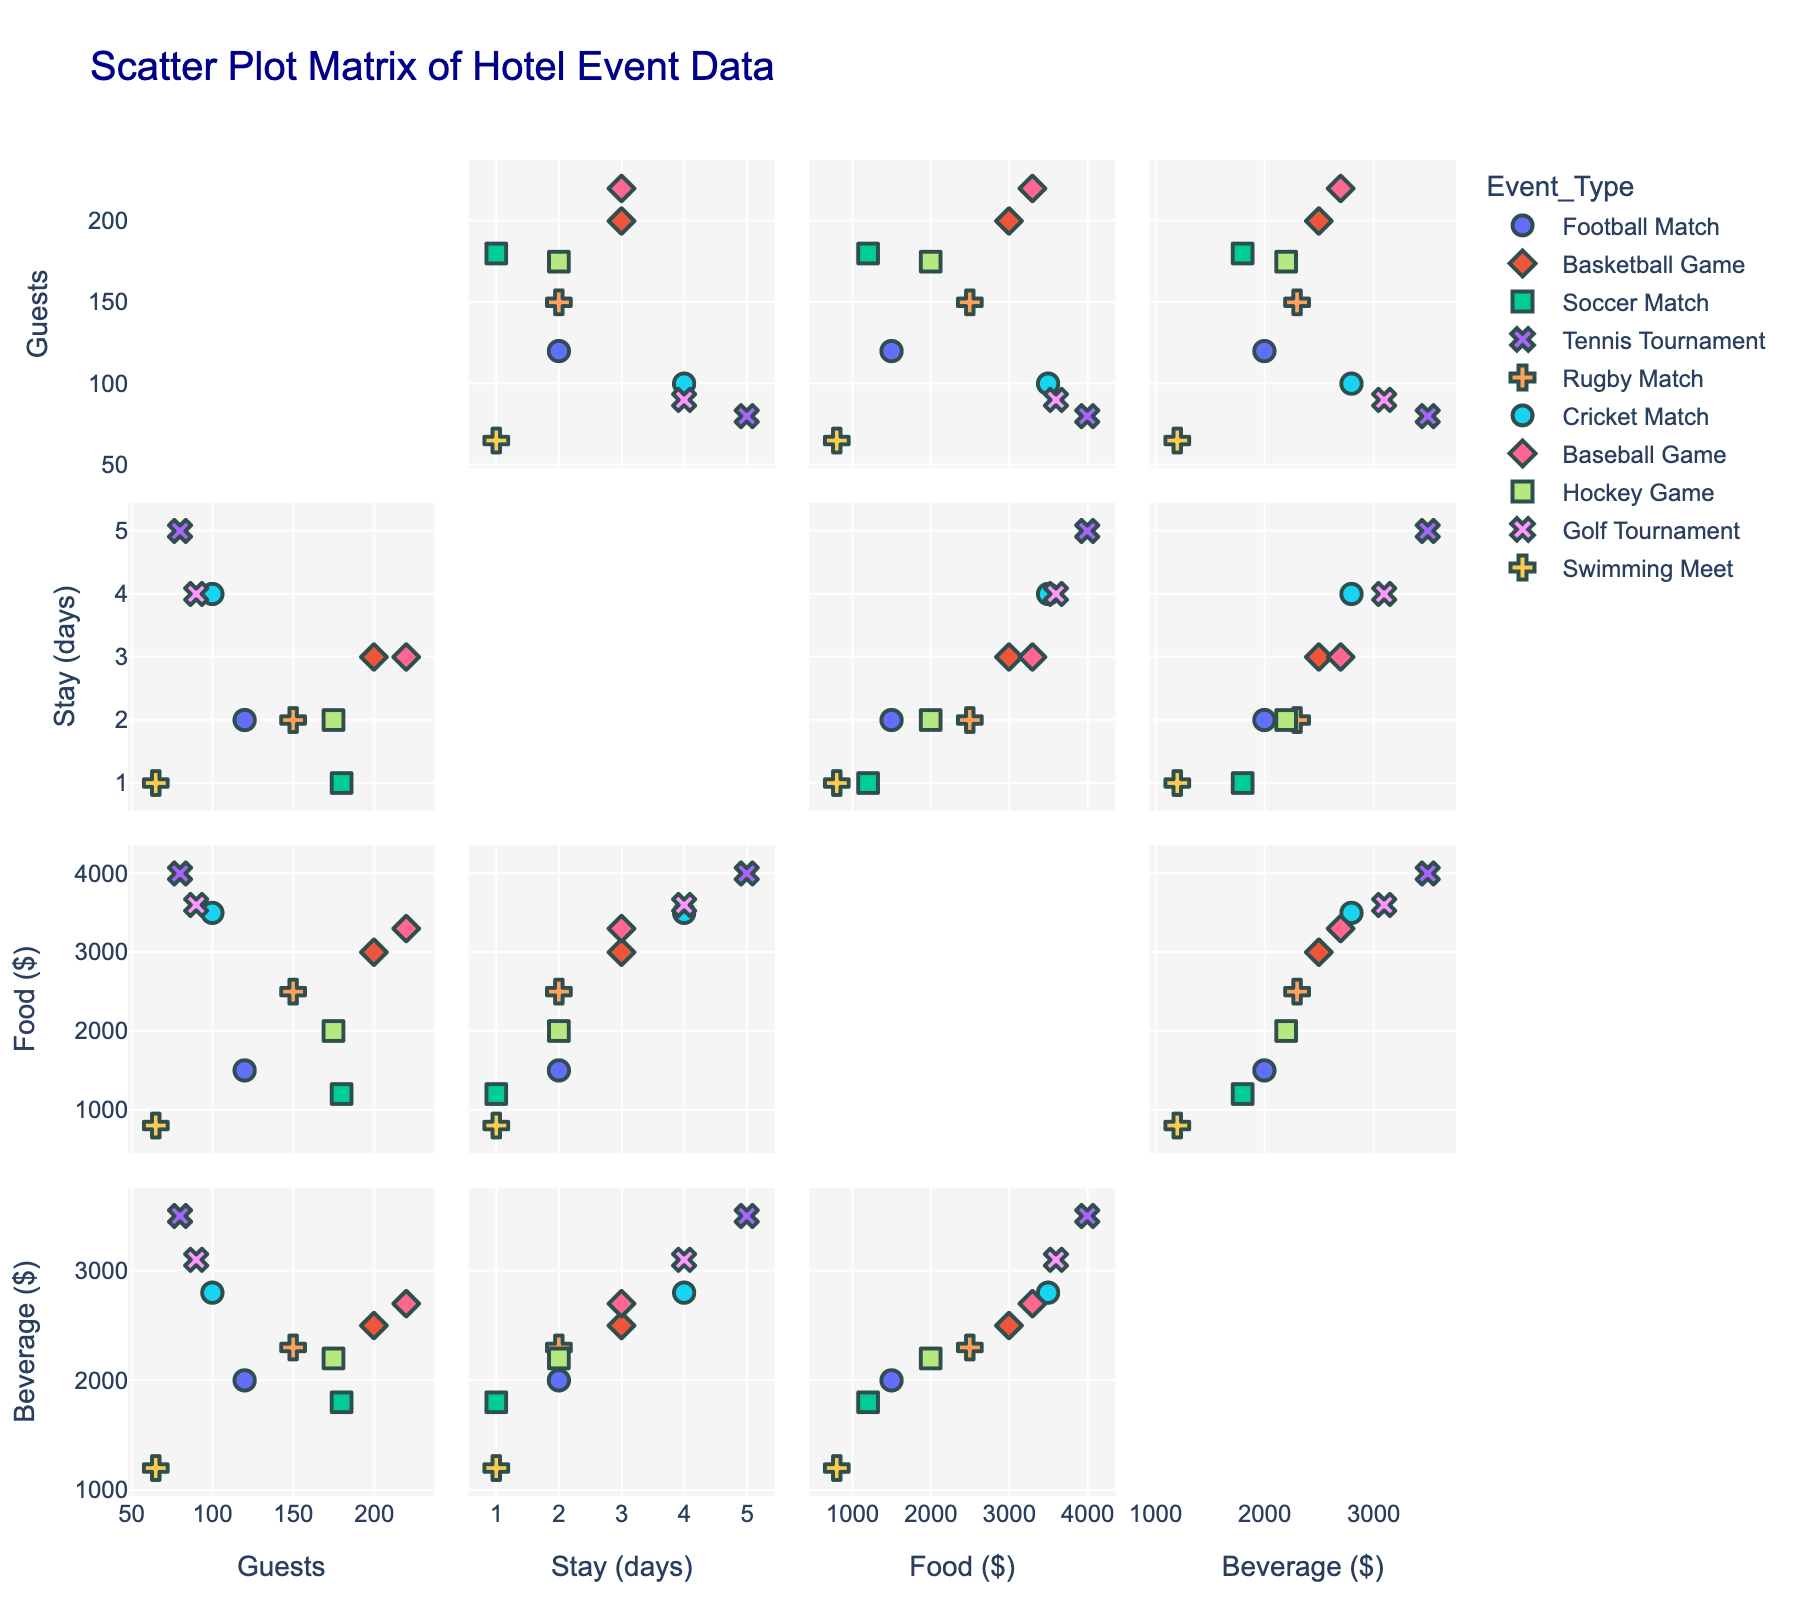How many events are represented in the scatter plot matrix? Count the number of distinct symbols or colors representing different events. Each unique color or symbol corresponds to a distinct event.
Answer: 10 Which event type has the highest number of guests? Look at the "Number_of_Guests" dimension and identify the event type with the highest data point.
Answer: Baseball Game What's the average duration of stay for Football Matches and Basketball Games? Find the data points for Football Matches and Basketball Games in the "Duration_of_Stay" dimension, and calculate the average of these durations. For Football Matches, the duration is 2 days, and for Basketball Games, it is 3 days. The average is (2 + 3) / 2 = 2.5 days.
Answer: 2.5 days Which event has higher beverage sales: Soccer Match or Swimming Meet? Locate the data points for Soccer Match and Swimming Meet in the "Beverage_Sales" dimension and compare their values. Soccer Match has 1800, and Swimming Meet has 1200.
Answer: Soccer Match What's the correlation between the number of guests and food sales? Examine the scatter points for the "Number_of_Guests" versus "Food_Sales" dimensions to identify any pattern. If the dots show an upward trend, it indicates a positive correlation.
Answer: Positive correlation For events with a duration of stay of 4 days, what are the food sales? Look at the "Duration_of_Stay" dimension to find events with a 4-day stay and then check their values in the "Food_Sales" dimension. The events are Cricket Match (3500) and Golf Tournament (3600).
Answer: 3500 and 3600 Which event has the lowest food sales, and how much are they? Identify the minimum value in the "Food_Sales" dimension and check the corresponding event type.
Answer: Swimming Meet, 800 Do longer stays generally correspond to higher food sales? Observe the relationship between "Duration_of_Stay" and "Food_Sales" dimensions. If the points trend upwards as the duration increases, longer stays correspond to higher food sales.
Answer: Yes Which event has both high food sales and high beverage sales? Look for data points in the scatter matrix where both "Food_Sales" and "Beverage_Sales" are high. Tennis Tournament has 4000 for Food Sales and 3500 for Beverage Sales.
Answer: Tennis Tournament 